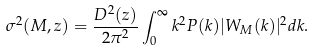Convert formula to latex. <formula><loc_0><loc_0><loc_500><loc_500>\sigma ^ { 2 } ( M , z ) = \frac { D ^ { 2 } ( z ) } { 2 \pi ^ { 2 } } \int _ { 0 } ^ { \infty } k ^ { 2 } P ( k ) | W _ { M } ( k ) | ^ { 2 } d k .</formula> 